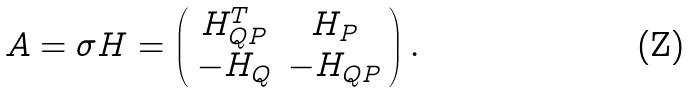Convert formula to latex. <formula><loc_0><loc_0><loc_500><loc_500>A = \sigma H = \left ( \begin{array} { c c } H _ { Q P } ^ { T } & H _ { P } \\ - H _ { Q } & - H _ { Q P } \\ \end{array} \right ) .</formula> 